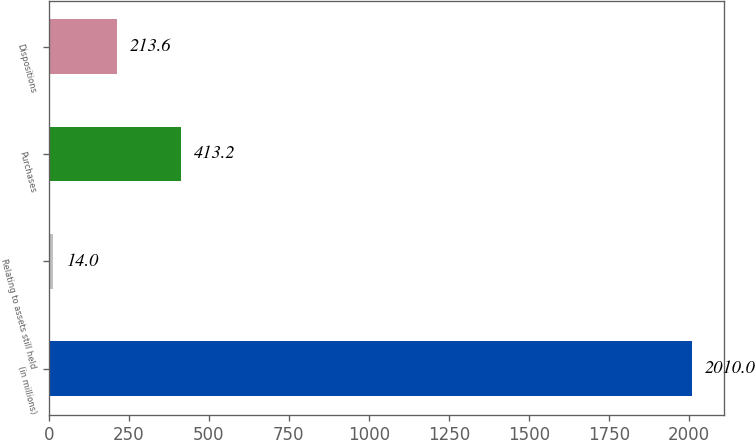Convert chart to OTSL. <chart><loc_0><loc_0><loc_500><loc_500><bar_chart><fcel>(in millions)<fcel>Relating to assets still held<fcel>Purchases<fcel>Dispositions<nl><fcel>2010<fcel>14<fcel>413.2<fcel>213.6<nl></chart> 